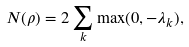<formula> <loc_0><loc_0><loc_500><loc_500>N ( \rho ) = 2 \sum _ { k } \max ( 0 , - \lambda _ { k } ) ,</formula> 